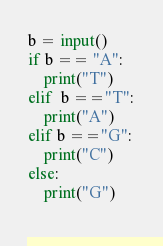Convert code to text. <code><loc_0><loc_0><loc_500><loc_500><_Python_>b = input()
if b == "A":
    print("T")
elif  b =="T":
    print("A")
elif b =="G":
    print("C")
else:
    print("G")
    
</code> 